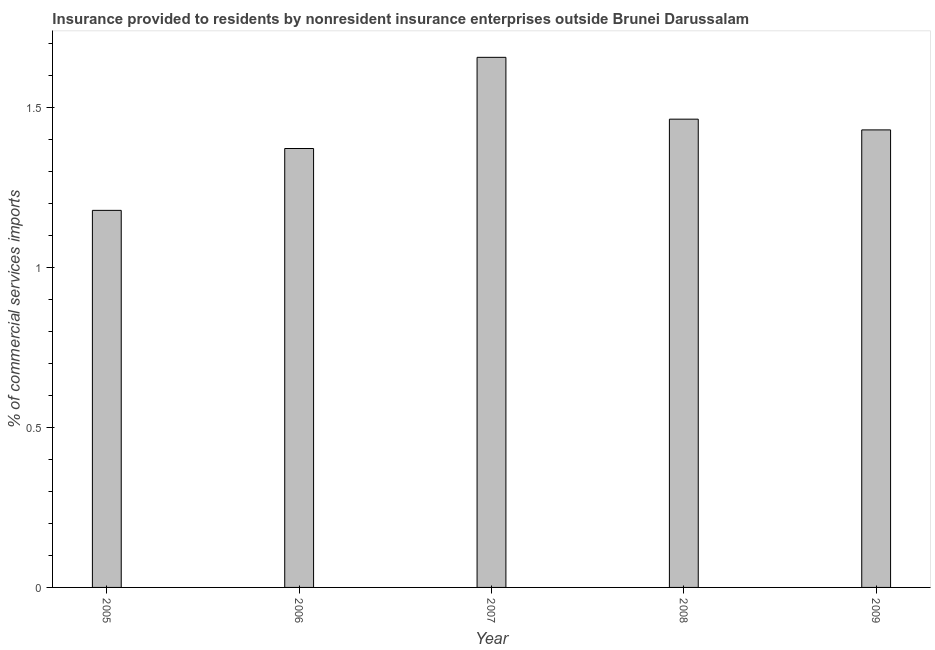Does the graph contain any zero values?
Offer a very short reply. No. Does the graph contain grids?
Your answer should be compact. No. What is the title of the graph?
Your answer should be very brief. Insurance provided to residents by nonresident insurance enterprises outside Brunei Darussalam. What is the label or title of the X-axis?
Your answer should be compact. Year. What is the label or title of the Y-axis?
Your response must be concise. % of commercial services imports. What is the insurance provided by non-residents in 2007?
Your response must be concise. 1.66. Across all years, what is the maximum insurance provided by non-residents?
Give a very brief answer. 1.66. Across all years, what is the minimum insurance provided by non-residents?
Your answer should be compact. 1.18. What is the sum of the insurance provided by non-residents?
Your response must be concise. 7.1. What is the difference between the insurance provided by non-residents in 2007 and 2008?
Provide a succinct answer. 0.19. What is the average insurance provided by non-residents per year?
Offer a very short reply. 1.42. What is the median insurance provided by non-residents?
Offer a terse response. 1.43. In how many years, is the insurance provided by non-residents greater than 1.2 %?
Your answer should be compact. 4. Do a majority of the years between 2008 and 2006 (inclusive) have insurance provided by non-residents greater than 1.3 %?
Your response must be concise. Yes. What is the ratio of the insurance provided by non-residents in 2006 to that in 2007?
Provide a succinct answer. 0.83. Is the insurance provided by non-residents in 2006 less than that in 2007?
Offer a terse response. Yes. Is the difference between the insurance provided by non-residents in 2006 and 2008 greater than the difference between any two years?
Offer a terse response. No. What is the difference between the highest and the second highest insurance provided by non-residents?
Offer a terse response. 0.19. Is the sum of the insurance provided by non-residents in 2005 and 2009 greater than the maximum insurance provided by non-residents across all years?
Ensure brevity in your answer.  Yes. What is the difference between the highest and the lowest insurance provided by non-residents?
Your answer should be very brief. 0.48. In how many years, is the insurance provided by non-residents greater than the average insurance provided by non-residents taken over all years?
Offer a very short reply. 3. How many bars are there?
Your response must be concise. 5. What is the difference between two consecutive major ticks on the Y-axis?
Your answer should be very brief. 0.5. What is the % of commercial services imports in 2005?
Your response must be concise. 1.18. What is the % of commercial services imports in 2006?
Offer a very short reply. 1.37. What is the % of commercial services imports in 2007?
Your answer should be compact. 1.66. What is the % of commercial services imports in 2008?
Give a very brief answer. 1.46. What is the % of commercial services imports of 2009?
Keep it short and to the point. 1.43. What is the difference between the % of commercial services imports in 2005 and 2006?
Offer a very short reply. -0.19. What is the difference between the % of commercial services imports in 2005 and 2007?
Provide a short and direct response. -0.48. What is the difference between the % of commercial services imports in 2005 and 2008?
Offer a very short reply. -0.29. What is the difference between the % of commercial services imports in 2005 and 2009?
Offer a terse response. -0.25. What is the difference between the % of commercial services imports in 2006 and 2007?
Give a very brief answer. -0.28. What is the difference between the % of commercial services imports in 2006 and 2008?
Give a very brief answer. -0.09. What is the difference between the % of commercial services imports in 2006 and 2009?
Your answer should be very brief. -0.06. What is the difference between the % of commercial services imports in 2007 and 2008?
Your answer should be very brief. 0.19. What is the difference between the % of commercial services imports in 2007 and 2009?
Provide a succinct answer. 0.23. What is the difference between the % of commercial services imports in 2008 and 2009?
Offer a terse response. 0.03. What is the ratio of the % of commercial services imports in 2005 to that in 2006?
Your answer should be compact. 0.86. What is the ratio of the % of commercial services imports in 2005 to that in 2007?
Make the answer very short. 0.71. What is the ratio of the % of commercial services imports in 2005 to that in 2008?
Make the answer very short. 0.81. What is the ratio of the % of commercial services imports in 2005 to that in 2009?
Ensure brevity in your answer.  0.82. What is the ratio of the % of commercial services imports in 2006 to that in 2007?
Your answer should be very brief. 0.83. What is the ratio of the % of commercial services imports in 2006 to that in 2008?
Provide a succinct answer. 0.94. What is the ratio of the % of commercial services imports in 2006 to that in 2009?
Your answer should be very brief. 0.96. What is the ratio of the % of commercial services imports in 2007 to that in 2008?
Ensure brevity in your answer.  1.13. What is the ratio of the % of commercial services imports in 2007 to that in 2009?
Make the answer very short. 1.16. 